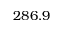Convert formula to latex. <formula><loc_0><loc_0><loc_500><loc_500>2 8 6 . 9</formula> 